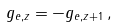Convert formula to latex. <formula><loc_0><loc_0><loc_500><loc_500>g _ { e , z } = - g _ { e , z + 1 } \, ,</formula> 